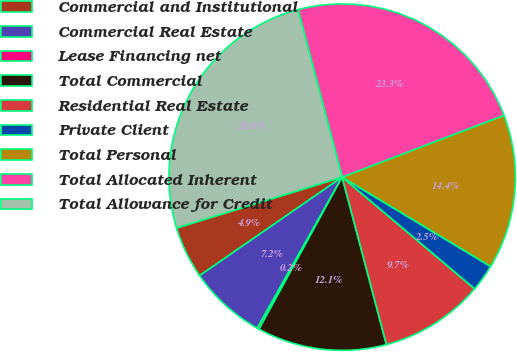<chart> <loc_0><loc_0><loc_500><loc_500><pie_chart><fcel>Commercial and Institutional<fcel>Commercial Real Estate<fcel>Lease Financing net<fcel>Total Commercial<fcel>Residential Real Estate<fcel>Private Client<fcel>Total Personal<fcel>Total Allocated Inherent<fcel>Total Allowance for Credit<nl><fcel>4.88%<fcel>7.22%<fcel>0.19%<fcel>12.08%<fcel>9.74%<fcel>2.53%<fcel>14.42%<fcel>23.3%<fcel>25.64%<nl></chart> 